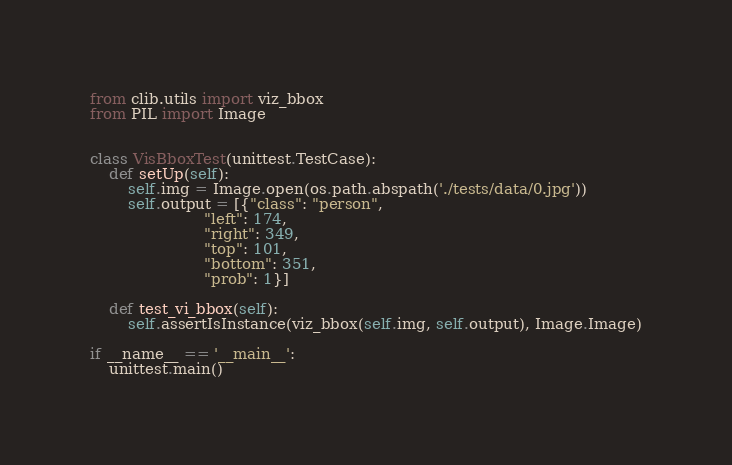<code> <loc_0><loc_0><loc_500><loc_500><_Python_>from clib.utils import viz_bbox
from PIL import Image


class VisBboxTest(unittest.TestCase):
    def setUp(self):
        self.img = Image.open(os.path.abspath('./tests/data/0.jpg'))
        self.output = [{"class": "person",
                        "left": 174,
                        "right": 349,
                        "top": 101,
                        "bottom": 351,
                        "prob": 1}]

    def test_vi_bbox(self):
        self.assertIsInstance(viz_bbox(self.img, self.output), Image.Image)

if __name__ == '__main__':
    unittest.main()
</code> 